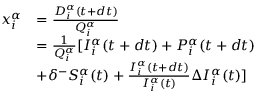Convert formula to latex. <formula><loc_0><loc_0><loc_500><loc_500>\begin{array} { r l } { x _ { i } ^ { \alpha } } & { = \frac { D _ { i } ^ { \alpha } ( t + d t ) } { Q _ { i } ^ { \alpha } } } \\ & { = \frac { 1 } { Q _ { i } ^ { \alpha } } [ I _ { i } ^ { \alpha } ( t + d t ) + P _ { i } ^ { \alpha } ( t + d t ) } \\ & { + \delta ^ { - } S _ { i } ^ { \alpha } ( t ) + \frac { I _ { i } ^ { \alpha } ( t + d t ) } { I _ { i } ^ { \alpha } ( t ) } \Delta I _ { i } ^ { \alpha } ( t ) ] } \end{array}</formula> 